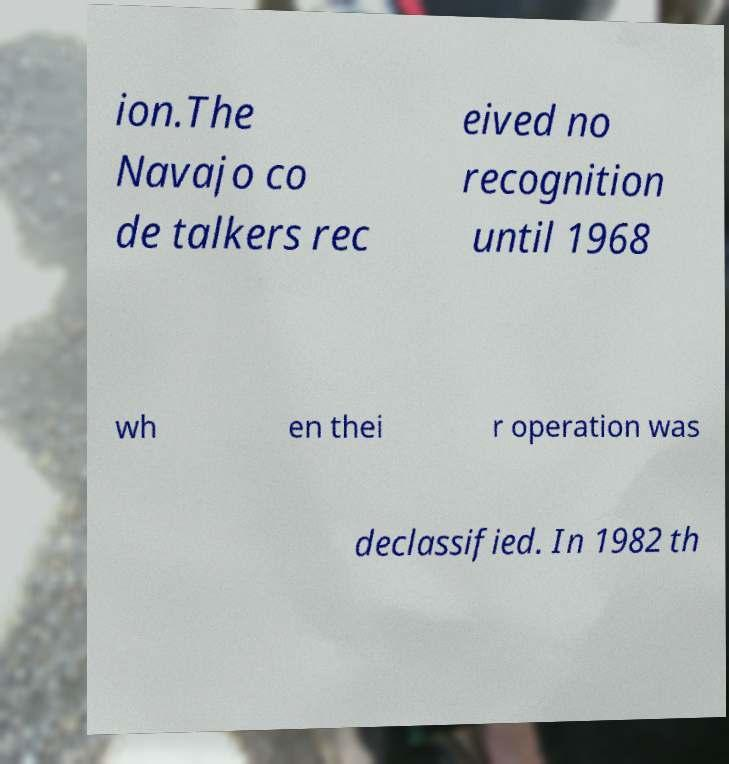Could you extract and type out the text from this image? ion.The Navajo co de talkers rec eived no recognition until 1968 wh en thei r operation was declassified. In 1982 th 